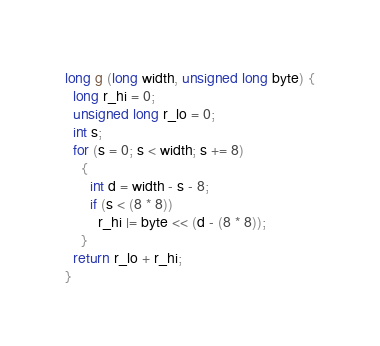Convert code to text. <code><loc_0><loc_0><loc_500><loc_500><_C_>long g (long width, unsigned long byte) {
  long r_hi = 0;
  unsigned long r_lo = 0;
  int s;
  for (s = 0; s < width; s += 8)
    {
      int d = width - s - 8;
      if (s < (8 * 8))
        r_hi |= byte << (d - (8 * 8));
    }
  return r_lo + r_hi;
}

</code> 